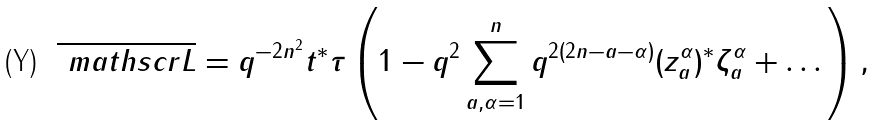<formula> <loc_0><loc_0><loc_500><loc_500>\overline { \ m a t h s c r { L } } = q ^ { - 2 n ^ { 2 } } t ^ { * } \tau \left ( 1 - q ^ { 2 } \sum _ { a , \alpha = 1 } ^ { n } q ^ { 2 ( 2 n - a - \alpha ) } ( z _ { a } ^ { \alpha } ) ^ { * } \zeta _ { a } ^ { \alpha } + \dots \right ) ,</formula> 